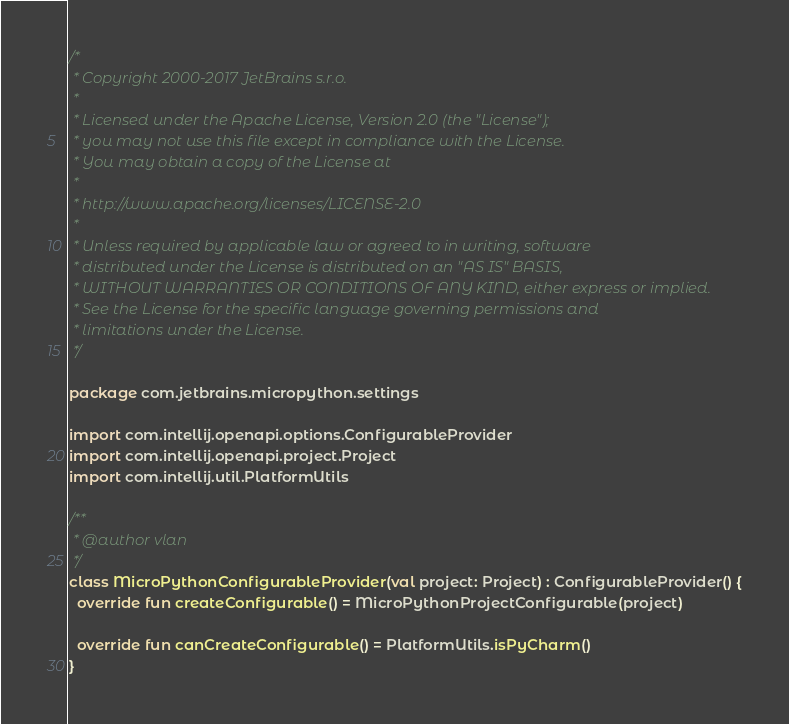<code> <loc_0><loc_0><loc_500><loc_500><_Kotlin_>/*
 * Copyright 2000-2017 JetBrains s.r.o.
 *
 * Licensed under the Apache License, Version 2.0 (the "License");
 * you may not use this file except in compliance with the License.
 * You may obtain a copy of the License at
 *
 * http://www.apache.org/licenses/LICENSE-2.0
 *
 * Unless required by applicable law or agreed to in writing, software
 * distributed under the License is distributed on an "AS IS" BASIS,
 * WITHOUT WARRANTIES OR CONDITIONS OF ANY KIND, either express or implied.
 * See the License for the specific language governing permissions and
 * limitations under the License.
 */

package com.jetbrains.micropython.settings

import com.intellij.openapi.options.ConfigurableProvider
import com.intellij.openapi.project.Project
import com.intellij.util.PlatformUtils

/**
 * @author vlan
 */
class MicroPythonConfigurableProvider(val project: Project) : ConfigurableProvider() {
  override fun createConfigurable() = MicroPythonProjectConfigurable(project)

  override fun canCreateConfigurable() = PlatformUtils.isPyCharm()
}</code> 